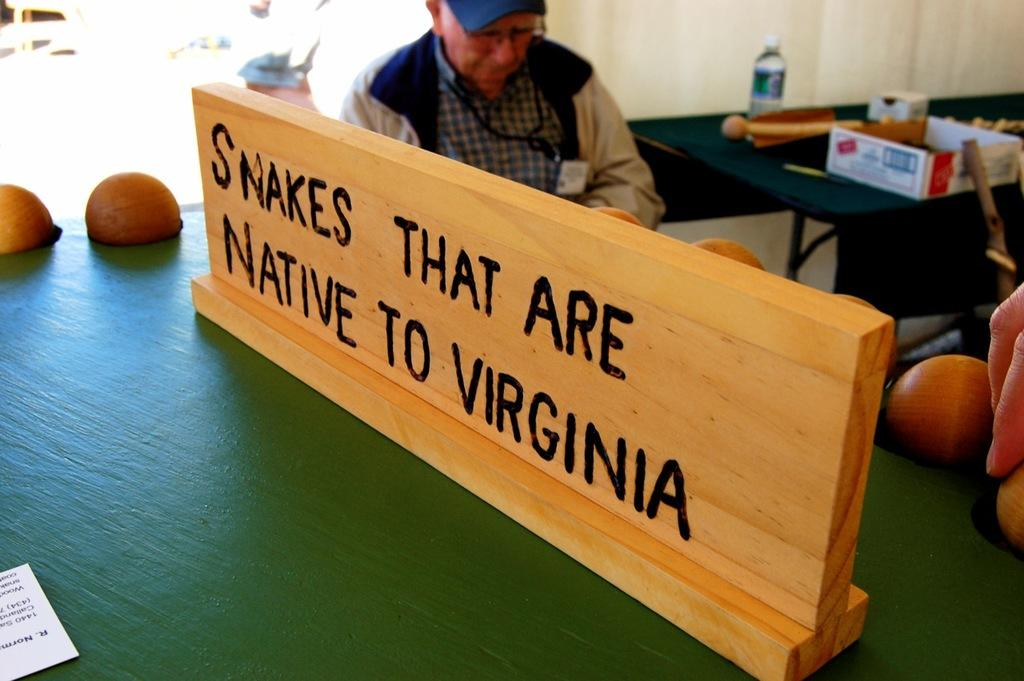What is written on the wooden board in the image? There is a wooden board with text in the image, but the specific text is not mentioned in the facts. What is the man in the image doing? There is a man sitting on a chair in the image, but his activity is not mentioned in the facts. What is on the table in the image? There is a disposable bottle and a cardboard carton on the table in the image. What is the cause of the birth depicted in the image? There is no birth depicted in the image; it features a wooden board with text, a man sitting on a chair, a table, a disposable bottle, and a cardboard carton. What type of horn is present in the image? There is no horn present in the image. 